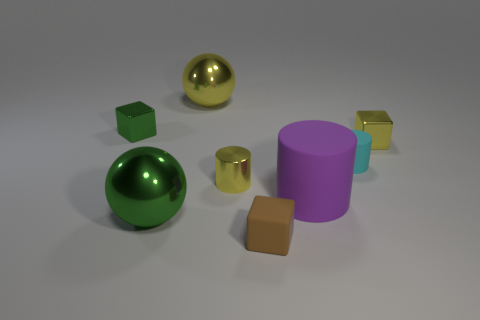What number of things are objects behind the green shiny sphere or metallic cubes that are to the right of the brown thing?
Your answer should be very brief. 6. Is the number of big purple things that are right of the tiny green cube greater than the number of cyan matte cylinders that are left of the rubber block?
Your response must be concise. Yes. There is a cylinder that is behind the small yellow thing that is on the left side of the rubber cylinder on the right side of the big purple rubber object; what is it made of?
Offer a very short reply. Rubber. There is a small yellow object on the right side of the small rubber cube; does it have the same shape as the tiny brown rubber object that is right of the small green thing?
Provide a short and direct response. Yes. Are there any brown matte cylinders that have the same size as the purple matte thing?
Ensure brevity in your answer.  No. What number of yellow objects are tiny matte cubes or big metal objects?
Your response must be concise. 1. What number of large metallic balls have the same color as the tiny rubber block?
Make the answer very short. 0. Is there any other thing that has the same shape as the tiny brown object?
Your response must be concise. Yes. How many spheres are either brown metal things or large rubber things?
Ensure brevity in your answer.  0. What color is the big ball that is in front of the green block?
Offer a very short reply. Green. 